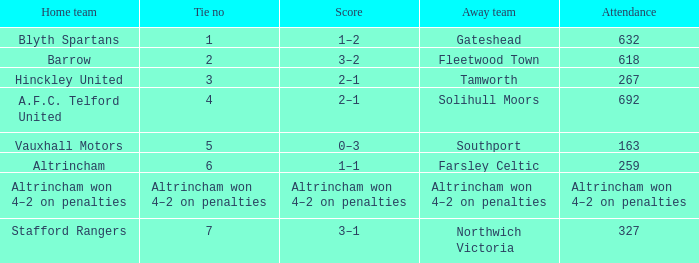Which away team that had a tie of 7? Northwich Victoria. 